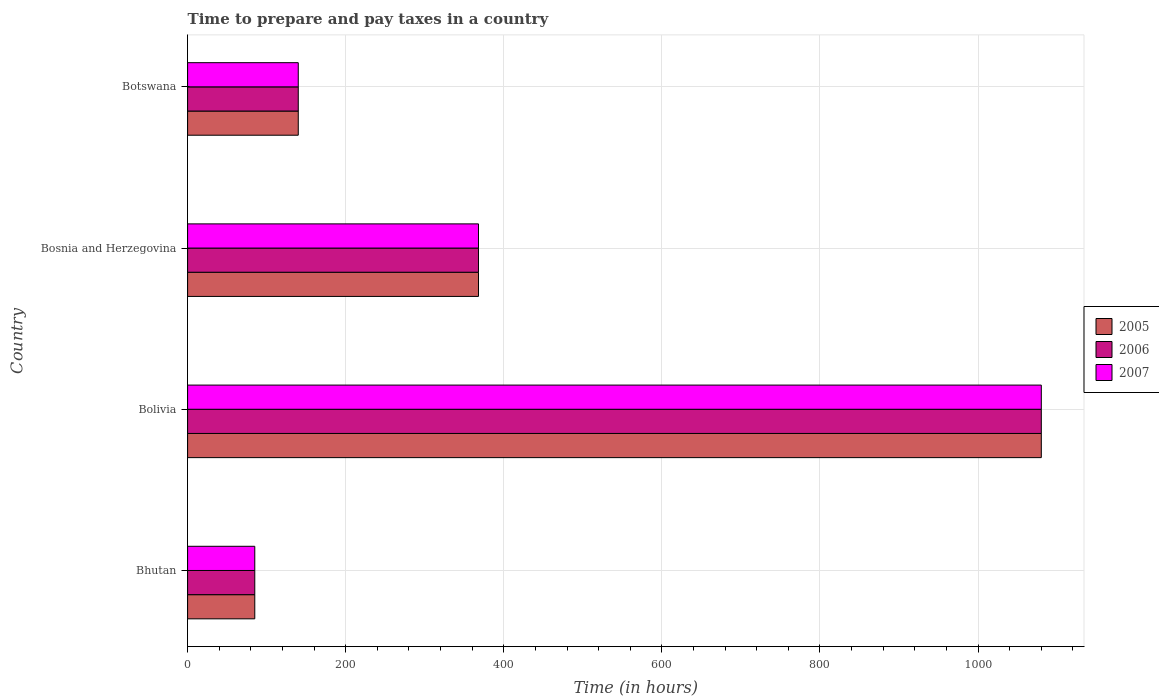How many different coloured bars are there?
Your answer should be very brief. 3. How many groups of bars are there?
Keep it short and to the point. 4. Are the number of bars per tick equal to the number of legend labels?
Your response must be concise. Yes. Are the number of bars on each tick of the Y-axis equal?
Give a very brief answer. Yes. How many bars are there on the 2nd tick from the top?
Your response must be concise. 3. What is the number of hours required to prepare and pay taxes in 2005 in Bosnia and Herzegovina?
Your answer should be very brief. 368. Across all countries, what is the maximum number of hours required to prepare and pay taxes in 2007?
Offer a terse response. 1080. Across all countries, what is the minimum number of hours required to prepare and pay taxes in 2006?
Ensure brevity in your answer.  85. In which country was the number of hours required to prepare and pay taxes in 2007 minimum?
Your answer should be very brief. Bhutan. What is the total number of hours required to prepare and pay taxes in 2005 in the graph?
Give a very brief answer. 1673. What is the difference between the number of hours required to prepare and pay taxes in 2006 in Bolivia and that in Botswana?
Make the answer very short. 940. What is the difference between the number of hours required to prepare and pay taxes in 2007 in Bolivia and the number of hours required to prepare and pay taxes in 2006 in Bhutan?
Make the answer very short. 995. What is the average number of hours required to prepare and pay taxes in 2005 per country?
Offer a very short reply. 418.25. In how many countries, is the number of hours required to prepare and pay taxes in 2006 greater than 400 hours?
Your response must be concise. 1. What is the ratio of the number of hours required to prepare and pay taxes in 2005 in Bhutan to that in Bolivia?
Offer a very short reply. 0.08. Is the difference between the number of hours required to prepare and pay taxes in 2007 in Bolivia and Bosnia and Herzegovina greater than the difference between the number of hours required to prepare and pay taxes in 2006 in Bolivia and Bosnia and Herzegovina?
Offer a terse response. No. What is the difference between the highest and the second highest number of hours required to prepare and pay taxes in 2005?
Your response must be concise. 712. What is the difference between the highest and the lowest number of hours required to prepare and pay taxes in 2007?
Offer a terse response. 995. In how many countries, is the number of hours required to prepare and pay taxes in 2007 greater than the average number of hours required to prepare and pay taxes in 2007 taken over all countries?
Provide a short and direct response. 1. Are all the bars in the graph horizontal?
Provide a succinct answer. Yes. Does the graph contain any zero values?
Provide a short and direct response. No. Does the graph contain grids?
Offer a terse response. Yes. Where does the legend appear in the graph?
Your answer should be very brief. Center right. What is the title of the graph?
Keep it short and to the point. Time to prepare and pay taxes in a country. What is the label or title of the X-axis?
Your response must be concise. Time (in hours). What is the label or title of the Y-axis?
Your answer should be very brief. Country. What is the Time (in hours) of 2005 in Bolivia?
Keep it short and to the point. 1080. What is the Time (in hours) in 2006 in Bolivia?
Offer a very short reply. 1080. What is the Time (in hours) of 2007 in Bolivia?
Offer a very short reply. 1080. What is the Time (in hours) in 2005 in Bosnia and Herzegovina?
Offer a terse response. 368. What is the Time (in hours) of 2006 in Bosnia and Herzegovina?
Ensure brevity in your answer.  368. What is the Time (in hours) of 2007 in Bosnia and Herzegovina?
Provide a succinct answer. 368. What is the Time (in hours) in 2005 in Botswana?
Make the answer very short. 140. What is the Time (in hours) in 2006 in Botswana?
Provide a short and direct response. 140. What is the Time (in hours) of 2007 in Botswana?
Your answer should be very brief. 140. Across all countries, what is the maximum Time (in hours) in 2005?
Make the answer very short. 1080. Across all countries, what is the maximum Time (in hours) of 2006?
Offer a very short reply. 1080. Across all countries, what is the maximum Time (in hours) of 2007?
Ensure brevity in your answer.  1080. What is the total Time (in hours) in 2005 in the graph?
Offer a very short reply. 1673. What is the total Time (in hours) of 2006 in the graph?
Your response must be concise. 1673. What is the total Time (in hours) in 2007 in the graph?
Give a very brief answer. 1673. What is the difference between the Time (in hours) in 2005 in Bhutan and that in Bolivia?
Give a very brief answer. -995. What is the difference between the Time (in hours) of 2006 in Bhutan and that in Bolivia?
Offer a very short reply. -995. What is the difference between the Time (in hours) of 2007 in Bhutan and that in Bolivia?
Provide a succinct answer. -995. What is the difference between the Time (in hours) of 2005 in Bhutan and that in Bosnia and Herzegovina?
Offer a very short reply. -283. What is the difference between the Time (in hours) of 2006 in Bhutan and that in Bosnia and Herzegovina?
Provide a succinct answer. -283. What is the difference between the Time (in hours) of 2007 in Bhutan and that in Bosnia and Herzegovina?
Give a very brief answer. -283. What is the difference between the Time (in hours) of 2005 in Bhutan and that in Botswana?
Keep it short and to the point. -55. What is the difference between the Time (in hours) in 2006 in Bhutan and that in Botswana?
Your answer should be compact. -55. What is the difference between the Time (in hours) in 2007 in Bhutan and that in Botswana?
Provide a short and direct response. -55. What is the difference between the Time (in hours) of 2005 in Bolivia and that in Bosnia and Herzegovina?
Offer a very short reply. 712. What is the difference between the Time (in hours) in 2006 in Bolivia and that in Bosnia and Herzegovina?
Offer a terse response. 712. What is the difference between the Time (in hours) of 2007 in Bolivia and that in Bosnia and Herzegovina?
Offer a very short reply. 712. What is the difference between the Time (in hours) in 2005 in Bolivia and that in Botswana?
Provide a succinct answer. 940. What is the difference between the Time (in hours) in 2006 in Bolivia and that in Botswana?
Your answer should be compact. 940. What is the difference between the Time (in hours) in 2007 in Bolivia and that in Botswana?
Offer a very short reply. 940. What is the difference between the Time (in hours) of 2005 in Bosnia and Herzegovina and that in Botswana?
Your answer should be very brief. 228. What is the difference between the Time (in hours) in 2006 in Bosnia and Herzegovina and that in Botswana?
Give a very brief answer. 228. What is the difference between the Time (in hours) of 2007 in Bosnia and Herzegovina and that in Botswana?
Offer a terse response. 228. What is the difference between the Time (in hours) in 2005 in Bhutan and the Time (in hours) in 2006 in Bolivia?
Your answer should be compact. -995. What is the difference between the Time (in hours) in 2005 in Bhutan and the Time (in hours) in 2007 in Bolivia?
Give a very brief answer. -995. What is the difference between the Time (in hours) in 2006 in Bhutan and the Time (in hours) in 2007 in Bolivia?
Keep it short and to the point. -995. What is the difference between the Time (in hours) in 2005 in Bhutan and the Time (in hours) in 2006 in Bosnia and Herzegovina?
Give a very brief answer. -283. What is the difference between the Time (in hours) in 2005 in Bhutan and the Time (in hours) in 2007 in Bosnia and Herzegovina?
Provide a succinct answer. -283. What is the difference between the Time (in hours) of 2006 in Bhutan and the Time (in hours) of 2007 in Bosnia and Herzegovina?
Your response must be concise. -283. What is the difference between the Time (in hours) in 2005 in Bhutan and the Time (in hours) in 2006 in Botswana?
Make the answer very short. -55. What is the difference between the Time (in hours) of 2005 in Bhutan and the Time (in hours) of 2007 in Botswana?
Ensure brevity in your answer.  -55. What is the difference between the Time (in hours) in 2006 in Bhutan and the Time (in hours) in 2007 in Botswana?
Ensure brevity in your answer.  -55. What is the difference between the Time (in hours) of 2005 in Bolivia and the Time (in hours) of 2006 in Bosnia and Herzegovina?
Ensure brevity in your answer.  712. What is the difference between the Time (in hours) in 2005 in Bolivia and the Time (in hours) in 2007 in Bosnia and Herzegovina?
Your response must be concise. 712. What is the difference between the Time (in hours) in 2006 in Bolivia and the Time (in hours) in 2007 in Bosnia and Herzegovina?
Make the answer very short. 712. What is the difference between the Time (in hours) in 2005 in Bolivia and the Time (in hours) in 2006 in Botswana?
Keep it short and to the point. 940. What is the difference between the Time (in hours) in 2005 in Bolivia and the Time (in hours) in 2007 in Botswana?
Provide a succinct answer. 940. What is the difference between the Time (in hours) in 2006 in Bolivia and the Time (in hours) in 2007 in Botswana?
Your answer should be compact. 940. What is the difference between the Time (in hours) of 2005 in Bosnia and Herzegovina and the Time (in hours) of 2006 in Botswana?
Your answer should be compact. 228. What is the difference between the Time (in hours) of 2005 in Bosnia and Herzegovina and the Time (in hours) of 2007 in Botswana?
Provide a short and direct response. 228. What is the difference between the Time (in hours) of 2006 in Bosnia and Herzegovina and the Time (in hours) of 2007 in Botswana?
Give a very brief answer. 228. What is the average Time (in hours) in 2005 per country?
Make the answer very short. 418.25. What is the average Time (in hours) in 2006 per country?
Offer a very short reply. 418.25. What is the average Time (in hours) in 2007 per country?
Your response must be concise. 418.25. What is the difference between the Time (in hours) of 2005 and Time (in hours) of 2006 in Bhutan?
Offer a very short reply. 0. What is the difference between the Time (in hours) in 2005 and Time (in hours) in 2007 in Bhutan?
Offer a very short reply. 0. What is the difference between the Time (in hours) in 2005 and Time (in hours) in 2007 in Bolivia?
Offer a terse response. 0. What is the difference between the Time (in hours) of 2005 and Time (in hours) of 2006 in Bosnia and Herzegovina?
Give a very brief answer. 0. What is the difference between the Time (in hours) in 2005 and Time (in hours) in 2007 in Bosnia and Herzegovina?
Give a very brief answer. 0. What is the difference between the Time (in hours) in 2005 and Time (in hours) in 2006 in Botswana?
Your answer should be very brief. 0. What is the ratio of the Time (in hours) of 2005 in Bhutan to that in Bolivia?
Keep it short and to the point. 0.08. What is the ratio of the Time (in hours) of 2006 in Bhutan to that in Bolivia?
Offer a very short reply. 0.08. What is the ratio of the Time (in hours) in 2007 in Bhutan to that in Bolivia?
Offer a terse response. 0.08. What is the ratio of the Time (in hours) of 2005 in Bhutan to that in Bosnia and Herzegovina?
Provide a succinct answer. 0.23. What is the ratio of the Time (in hours) of 2006 in Bhutan to that in Bosnia and Herzegovina?
Your answer should be compact. 0.23. What is the ratio of the Time (in hours) in 2007 in Bhutan to that in Bosnia and Herzegovina?
Give a very brief answer. 0.23. What is the ratio of the Time (in hours) of 2005 in Bhutan to that in Botswana?
Keep it short and to the point. 0.61. What is the ratio of the Time (in hours) of 2006 in Bhutan to that in Botswana?
Your answer should be very brief. 0.61. What is the ratio of the Time (in hours) of 2007 in Bhutan to that in Botswana?
Your response must be concise. 0.61. What is the ratio of the Time (in hours) in 2005 in Bolivia to that in Bosnia and Herzegovina?
Your answer should be compact. 2.93. What is the ratio of the Time (in hours) in 2006 in Bolivia to that in Bosnia and Herzegovina?
Your answer should be very brief. 2.93. What is the ratio of the Time (in hours) in 2007 in Bolivia to that in Bosnia and Herzegovina?
Make the answer very short. 2.93. What is the ratio of the Time (in hours) in 2005 in Bolivia to that in Botswana?
Offer a terse response. 7.71. What is the ratio of the Time (in hours) of 2006 in Bolivia to that in Botswana?
Your answer should be very brief. 7.71. What is the ratio of the Time (in hours) in 2007 in Bolivia to that in Botswana?
Provide a succinct answer. 7.71. What is the ratio of the Time (in hours) in 2005 in Bosnia and Herzegovina to that in Botswana?
Ensure brevity in your answer.  2.63. What is the ratio of the Time (in hours) of 2006 in Bosnia and Herzegovina to that in Botswana?
Ensure brevity in your answer.  2.63. What is the ratio of the Time (in hours) in 2007 in Bosnia and Herzegovina to that in Botswana?
Provide a short and direct response. 2.63. What is the difference between the highest and the second highest Time (in hours) of 2005?
Make the answer very short. 712. What is the difference between the highest and the second highest Time (in hours) of 2006?
Give a very brief answer. 712. What is the difference between the highest and the second highest Time (in hours) in 2007?
Offer a very short reply. 712. What is the difference between the highest and the lowest Time (in hours) in 2005?
Your response must be concise. 995. What is the difference between the highest and the lowest Time (in hours) in 2006?
Provide a succinct answer. 995. What is the difference between the highest and the lowest Time (in hours) of 2007?
Offer a very short reply. 995. 